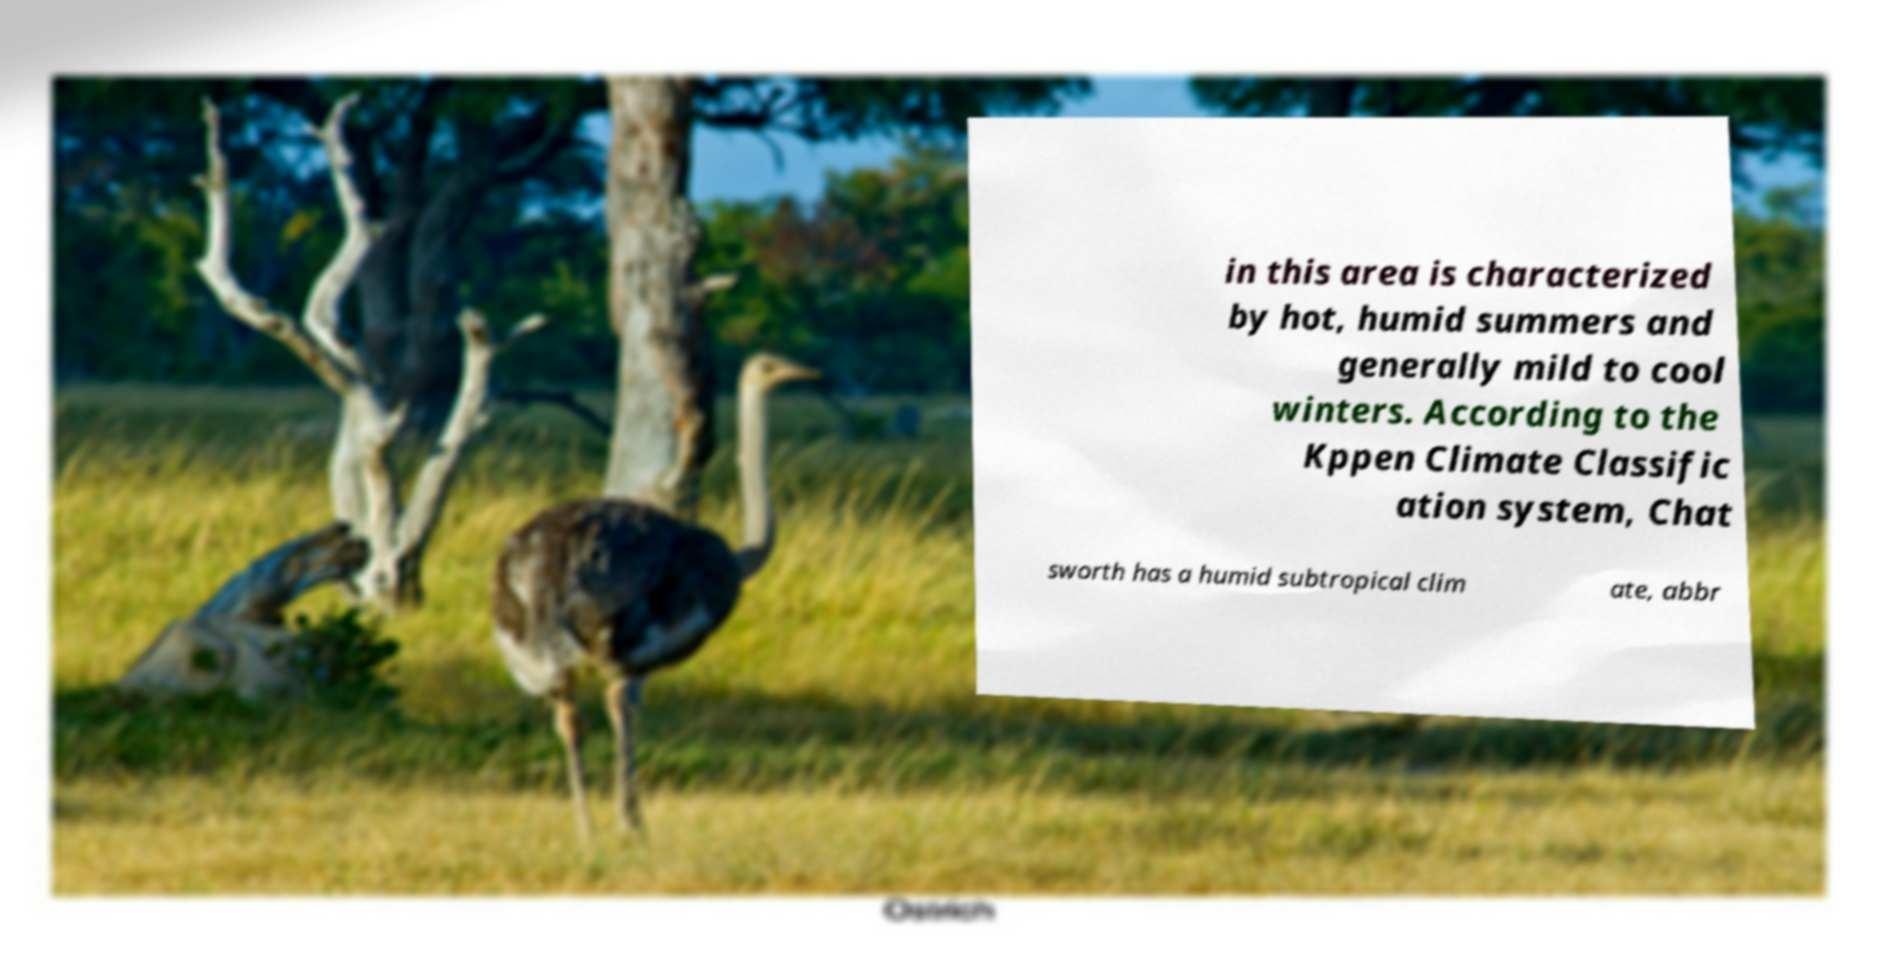For documentation purposes, I need the text within this image transcribed. Could you provide that? in this area is characterized by hot, humid summers and generally mild to cool winters. According to the Kppen Climate Classific ation system, Chat sworth has a humid subtropical clim ate, abbr 